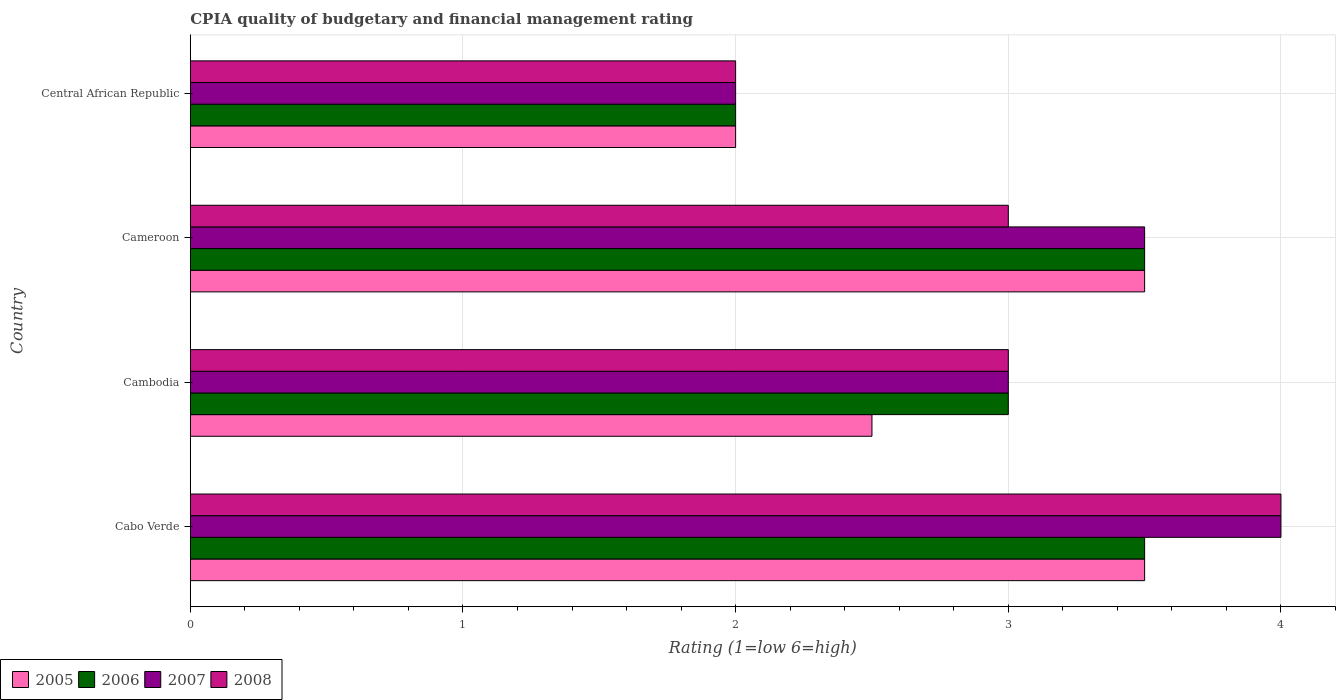Are the number of bars per tick equal to the number of legend labels?
Offer a terse response. Yes. Are the number of bars on each tick of the Y-axis equal?
Provide a short and direct response. Yes. What is the label of the 2nd group of bars from the top?
Your answer should be compact. Cameroon. In how many cases, is the number of bars for a given country not equal to the number of legend labels?
Provide a short and direct response. 0. Across all countries, what is the minimum CPIA rating in 2005?
Your answer should be very brief. 2. In which country was the CPIA rating in 2007 maximum?
Offer a very short reply. Cabo Verde. In which country was the CPIA rating in 2008 minimum?
Offer a very short reply. Central African Republic. What is the total CPIA rating in 2007 in the graph?
Your answer should be compact. 12.5. What is the difference between the CPIA rating in 2008 in Cameroon and that in Central African Republic?
Your answer should be very brief. 1. What is the difference between the CPIA rating in 2007 and CPIA rating in 2006 in Central African Republic?
Offer a terse response. 0. Is the CPIA rating in 2005 in Cabo Verde less than that in Cambodia?
Provide a succinct answer. No. What is the difference between the highest and the second highest CPIA rating in 2008?
Provide a succinct answer. 1. What does the 1st bar from the top in Cameroon represents?
Keep it short and to the point. 2008. What does the 4th bar from the bottom in Cambodia represents?
Offer a terse response. 2008. How many bars are there?
Ensure brevity in your answer.  16. Are the values on the major ticks of X-axis written in scientific E-notation?
Provide a succinct answer. No. Does the graph contain any zero values?
Provide a succinct answer. No. How are the legend labels stacked?
Your answer should be compact. Horizontal. What is the title of the graph?
Offer a terse response. CPIA quality of budgetary and financial management rating. What is the label or title of the X-axis?
Your response must be concise. Rating (1=low 6=high). What is the label or title of the Y-axis?
Provide a succinct answer. Country. What is the Rating (1=low 6=high) of 2005 in Cabo Verde?
Offer a very short reply. 3.5. What is the Rating (1=low 6=high) of 2006 in Cabo Verde?
Offer a terse response. 3.5. What is the Rating (1=low 6=high) in 2007 in Cabo Verde?
Ensure brevity in your answer.  4. What is the Rating (1=low 6=high) of 2008 in Cabo Verde?
Your answer should be compact. 4. What is the Rating (1=low 6=high) of 2005 in Cambodia?
Your answer should be very brief. 2.5. What is the Rating (1=low 6=high) of 2008 in Cambodia?
Offer a terse response. 3. What is the Rating (1=low 6=high) in 2005 in Cameroon?
Your answer should be very brief. 3.5. What is the Rating (1=low 6=high) of 2007 in Cameroon?
Offer a very short reply. 3.5. What is the Rating (1=low 6=high) of 2005 in Central African Republic?
Provide a succinct answer. 2. What is the Rating (1=low 6=high) of 2006 in Central African Republic?
Make the answer very short. 2. What is the Rating (1=low 6=high) in 2008 in Central African Republic?
Your response must be concise. 2. Across all countries, what is the maximum Rating (1=low 6=high) of 2005?
Your answer should be compact. 3.5. Across all countries, what is the maximum Rating (1=low 6=high) in 2006?
Make the answer very short. 3.5. What is the total Rating (1=low 6=high) in 2005 in the graph?
Give a very brief answer. 11.5. What is the total Rating (1=low 6=high) in 2006 in the graph?
Your answer should be very brief. 12. What is the total Rating (1=low 6=high) of 2007 in the graph?
Keep it short and to the point. 12.5. What is the total Rating (1=low 6=high) in 2008 in the graph?
Provide a succinct answer. 12. What is the difference between the Rating (1=low 6=high) in 2005 in Cabo Verde and that in Cambodia?
Your response must be concise. 1. What is the difference between the Rating (1=low 6=high) in 2006 in Cabo Verde and that in Cambodia?
Keep it short and to the point. 0.5. What is the difference between the Rating (1=low 6=high) in 2007 in Cabo Verde and that in Cameroon?
Provide a short and direct response. 0.5. What is the difference between the Rating (1=low 6=high) in 2008 in Cabo Verde and that in Cameroon?
Provide a succinct answer. 1. What is the difference between the Rating (1=low 6=high) of 2006 in Cabo Verde and that in Central African Republic?
Keep it short and to the point. 1.5. What is the difference between the Rating (1=low 6=high) of 2007 in Cabo Verde and that in Central African Republic?
Give a very brief answer. 2. What is the difference between the Rating (1=low 6=high) in 2007 in Cambodia and that in Cameroon?
Your response must be concise. -0.5. What is the difference between the Rating (1=low 6=high) of 2006 in Cambodia and that in Central African Republic?
Make the answer very short. 1. What is the difference between the Rating (1=low 6=high) of 2007 in Cambodia and that in Central African Republic?
Provide a short and direct response. 1. What is the difference between the Rating (1=low 6=high) of 2005 in Cameroon and that in Central African Republic?
Provide a succinct answer. 1.5. What is the difference between the Rating (1=low 6=high) in 2008 in Cameroon and that in Central African Republic?
Your answer should be very brief. 1. What is the difference between the Rating (1=low 6=high) of 2006 in Cabo Verde and the Rating (1=low 6=high) of 2007 in Cambodia?
Offer a terse response. 0.5. What is the difference between the Rating (1=low 6=high) of 2007 in Cabo Verde and the Rating (1=low 6=high) of 2008 in Cambodia?
Ensure brevity in your answer.  1. What is the difference between the Rating (1=low 6=high) of 2005 in Cabo Verde and the Rating (1=low 6=high) of 2006 in Cameroon?
Your answer should be very brief. 0. What is the difference between the Rating (1=low 6=high) in 2005 in Cabo Verde and the Rating (1=low 6=high) in 2008 in Cameroon?
Provide a short and direct response. 0.5. What is the difference between the Rating (1=low 6=high) in 2007 in Cabo Verde and the Rating (1=low 6=high) in 2008 in Cameroon?
Your answer should be very brief. 1. What is the difference between the Rating (1=low 6=high) of 2005 in Cabo Verde and the Rating (1=low 6=high) of 2006 in Central African Republic?
Your answer should be compact. 1.5. What is the difference between the Rating (1=low 6=high) of 2005 in Cabo Verde and the Rating (1=low 6=high) of 2008 in Central African Republic?
Offer a terse response. 1.5. What is the difference between the Rating (1=low 6=high) in 2005 in Cambodia and the Rating (1=low 6=high) in 2007 in Cameroon?
Keep it short and to the point. -1. What is the difference between the Rating (1=low 6=high) in 2005 in Cambodia and the Rating (1=low 6=high) in 2007 in Central African Republic?
Provide a succinct answer. 0.5. What is the difference between the Rating (1=low 6=high) in 2005 in Cambodia and the Rating (1=low 6=high) in 2008 in Central African Republic?
Give a very brief answer. 0.5. What is the difference between the Rating (1=low 6=high) of 2006 in Cambodia and the Rating (1=low 6=high) of 2007 in Central African Republic?
Your answer should be very brief. 1. What is the difference between the Rating (1=low 6=high) of 2006 in Cambodia and the Rating (1=low 6=high) of 2008 in Central African Republic?
Your answer should be very brief. 1. What is the difference between the Rating (1=low 6=high) of 2005 in Cameroon and the Rating (1=low 6=high) of 2006 in Central African Republic?
Your answer should be compact. 1.5. What is the difference between the Rating (1=low 6=high) in 2005 in Cameroon and the Rating (1=low 6=high) in 2007 in Central African Republic?
Give a very brief answer. 1.5. What is the difference between the Rating (1=low 6=high) of 2006 in Cameroon and the Rating (1=low 6=high) of 2007 in Central African Republic?
Give a very brief answer. 1.5. What is the average Rating (1=low 6=high) of 2005 per country?
Give a very brief answer. 2.88. What is the average Rating (1=low 6=high) of 2007 per country?
Your response must be concise. 3.12. What is the difference between the Rating (1=low 6=high) of 2005 and Rating (1=low 6=high) of 2007 in Cabo Verde?
Your answer should be very brief. -0.5. What is the difference between the Rating (1=low 6=high) in 2007 and Rating (1=low 6=high) in 2008 in Cabo Verde?
Make the answer very short. 0. What is the difference between the Rating (1=low 6=high) in 2006 and Rating (1=low 6=high) in 2008 in Cambodia?
Provide a succinct answer. 0. What is the difference between the Rating (1=low 6=high) in 2006 and Rating (1=low 6=high) in 2008 in Cameroon?
Keep it short and to the point. 0.5. What is the difference between the Rating (1=low 6=high) in 2007 and Rating (1=low 6=high) in 2008 in Cameroon?
Ensure brevity in your answer.  0.5. What is the difference between the Rating (1=low 6=high) of 2005 and Rating (1=low 6=high) of 2006 in Central African Republic?
Give a very brief answer. 0. What is the difference between the Rating (1=low 6=high) of 2007 and Rating (1=low 6=high) of 2008 in Central African Republic?
Give a very brief answer. 0. What is the ratio of the Rating (1=low 6=high) in 2005 in Cabo Verde to that in Cambodia?
Offer a very short reply. 1.4. What is the ratio of the Rating (1=low 6=high) in 2006 in Cabo Verde to that in Cambodia?
Ensure brevity in your answer.  1.17. What is the ratio of the Rating (1=low 6=high) of 2007 in Cabo Verde to that in Cambodia?
Make the answer very short. 1.33. What is the ratio of the Rating (1=low 6=high) of 2008 in Cabo Verde to that in Cambodia?
Keep it short and to the point. 1.33. What is the ratio of the Rating (1=low 6=high) in 2006 in Cabo Verde to that in Cameroon?
Your response must be concise. 1. What is the ratio of the Rating (1=low 6=high) in 2005 in Cabo Verde to that in Central African Republic?
Offer a terse response. 1.75. What is the ratio of the Rating (1=low 6=high) of 2008 in Cabo Verde to that in Central African Republic?
Ensure brevity in your answer.  2. What is the ratio of the Rating (1=low 6=high) in 2006 in Cambodia to that in Cameroon?
Your response must be concise. 0.86. What is the ratio of the Rating (1=low 6=high) of 2005 in Cambodia to that in Central African Republic?
Make the answer very short. 1.25. What is the ratio of the Rating (1=low 6=high) in 2006 in Cambodia to that in Central African Republic?
Your answer should be compact. 1.5. What is the ratio of the Rating (1=low 6=high) of 2008 in Cambodia to that in Central African Republic?
Offer a very short reply. 1.5. What is the ratio of the Rating (1=low 6=high) of 2005 in Cameroon to that in Central African Republic?
Give a very brief answer. 1.75. What is the ratio of the Rating (1=low 6=high) of 2006 in Cameroon to that in Central African Republic?
Keep it short and to the point. 1.75. What is the ratio of the Rating (1=low 6=high) of 2008 in Cameroon to that in Central African Republic?
Keep it short and to the point. 1.5. What is the difference between the highest and the second highest Rating (1=low 6=high) of 2008?
Your answer should be compact. 1. What is the difference between the highest and the lowest Rating (1=low 6=high) in 2006?
Provide a short and direct response. 1.5. What is the difference between the highest and the lowest Rating (1=low 6=high) of 2007?
Provide a short and direct response. 2. What is the difference between the highest and the lowest Rating (1=low 6=high) of 2008?
Your response must be concise. 2. 